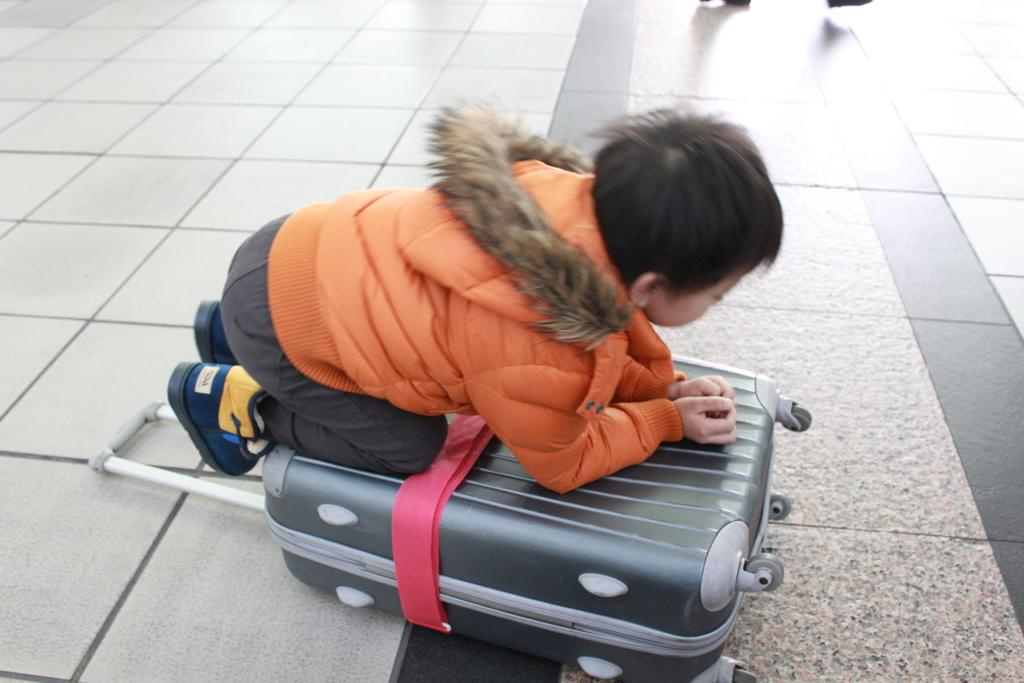Who is the main subject in the image? There is a boy in the image. What is the boy doing in the image? The boy is on a luggage bag. What is the boy wearing in the image? The boy is wearing an orange color jacket. What type of lamp is the boy using as a guide in the image? There is no lamp present in the image, and the boy is not using any guide. 